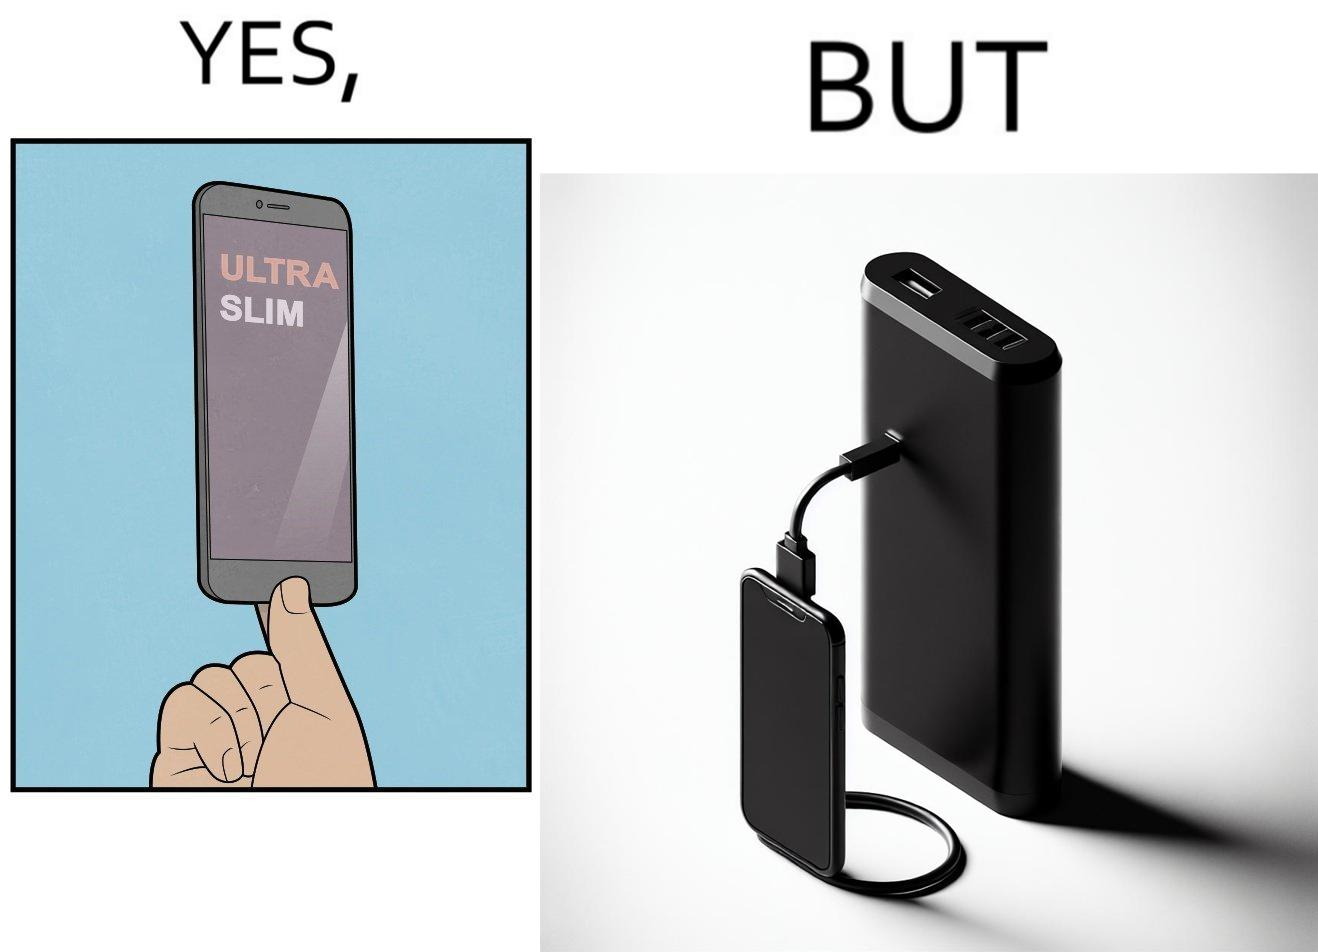Why is this image considered satirical? The image is satirical because even though the mobile phone has been developed to be very slim, it requires frequent recharging which makes the mobile phone useless without a big, heavy and thick power bank. 